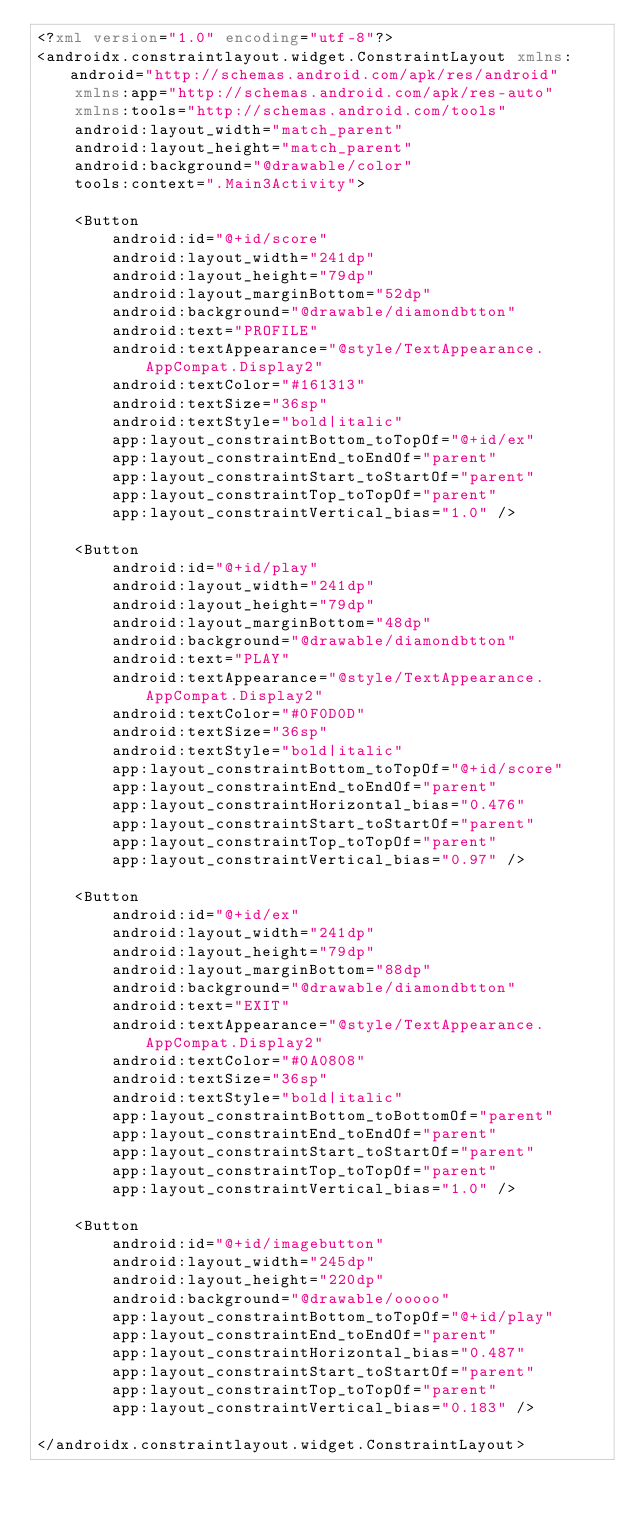Convert code to text. <code><loc_0><loc_0><loc_500><loc_500><_XML_><?xml version="1.0" encoding="utf-8"?>
<androidx.constraintlayout.widget.ConstraintLayout xmlns:android="http://schemas.android.com/apk/res/android"
    xmlns:app="http://schemas.android.com/apk/res-auto"
    xmlns:tools="http://schemas.android.com/tools"
    android:layout_width="match_parent"
    android:layout_height="match_parent"
    android:background="@drawable/color"
    tools:context=".Main3Activity">

    <Button
        android:id="@+id/score"
        android:layout_width="241dp"
        android:layout_height="79dp"
        android:layout_marginBottom="52dp"
        android:background="@drawable/diamondbtton"
        android:text="PROFILE"
        android:textAppearance="@style/TextAppearance.AppCompat.Display2"
        android:textColor="#161313"
        android:textSize="36sp"
        android:textStyle="bold|italic"
        app:layout_constraintBottom_toTopOf="@+id/ex"
        app:layout_constraintEnd_toEndOf="parent"
        app:layout_constraintStart_toStartOf="parent"
        app:layout_constraintTop_toTopOf="parent"
        app:layout_constraintVertical_bias="1.0" />

    <Button
        android:id="@+id/play"
        android:layout_width="241dp"
        android:layout_height="79dp"
        android:layout_marginBottom="48dp"
        android:background="@drawable/diamondbtton"
        android:text="PLAY"
        android:textAppearance="@style/TextAppearance.AppCompat.Display2"
        android:textColor="#0F0D0D"
        android:textSize="36sp"
        android:textStyle="bold|italic"
        app:layout_constraintBottom_toTopOf="@+id/score"
        app:layout_constraintEnd_toEndOf="parent"
        app:layout_constraintHorizontal_bias="0.476"
        app:layout_constraintStart_toStartOf="parent"
        app:layout_constraintTop_toTopOf="parent"
        app:layout_constraintVertical_bias="0.97" />

    <Button
        android:id="@+id/ex"
        android:layout_width="241dp"
        android:layout_height="79dp"
        android:layout_marginBottom="88dp"
        android:background="@drawable/diamondbtton"
        android:text="EXIT"
        android:textAppearance="@style/TextAppearance.AppCompat.Display2"
        android:textColor="#0A0808"
        android:textSize="36sp"
        android:textStyle="bold|italic"
        app:layout_constraintBottom_toBottomOf="parent"
        app:layout_constraintEnd_toEndOf="parent"
        app:layout_constraintStart_toStartOf="parent"
        app:layout_constraintTop_toTopOf="parent"
        app:layout_constraintVertical_bias="1.0" />

    <Button
        android:id="@+id/imagebutton"
        android:layout_width="245dp"
        android:layout_height="220dp"
        android:background="@drawable/ooooo"
        app:layout_constraintBottom_toTopOf="@+id/play"
        app:layout_constraintEnd_toEndOf="parent"
        app:layout_constraintHorizontal_bias="0.487"
        app:layout_constraintStart_toStartOf="parent"
        app:layout_constraintTop_toTopOf="parent"
        app:layout_constraintVertical_bias="0.183" />

</androidx.constraintlayout.widget.ConstraintLayout></code> 